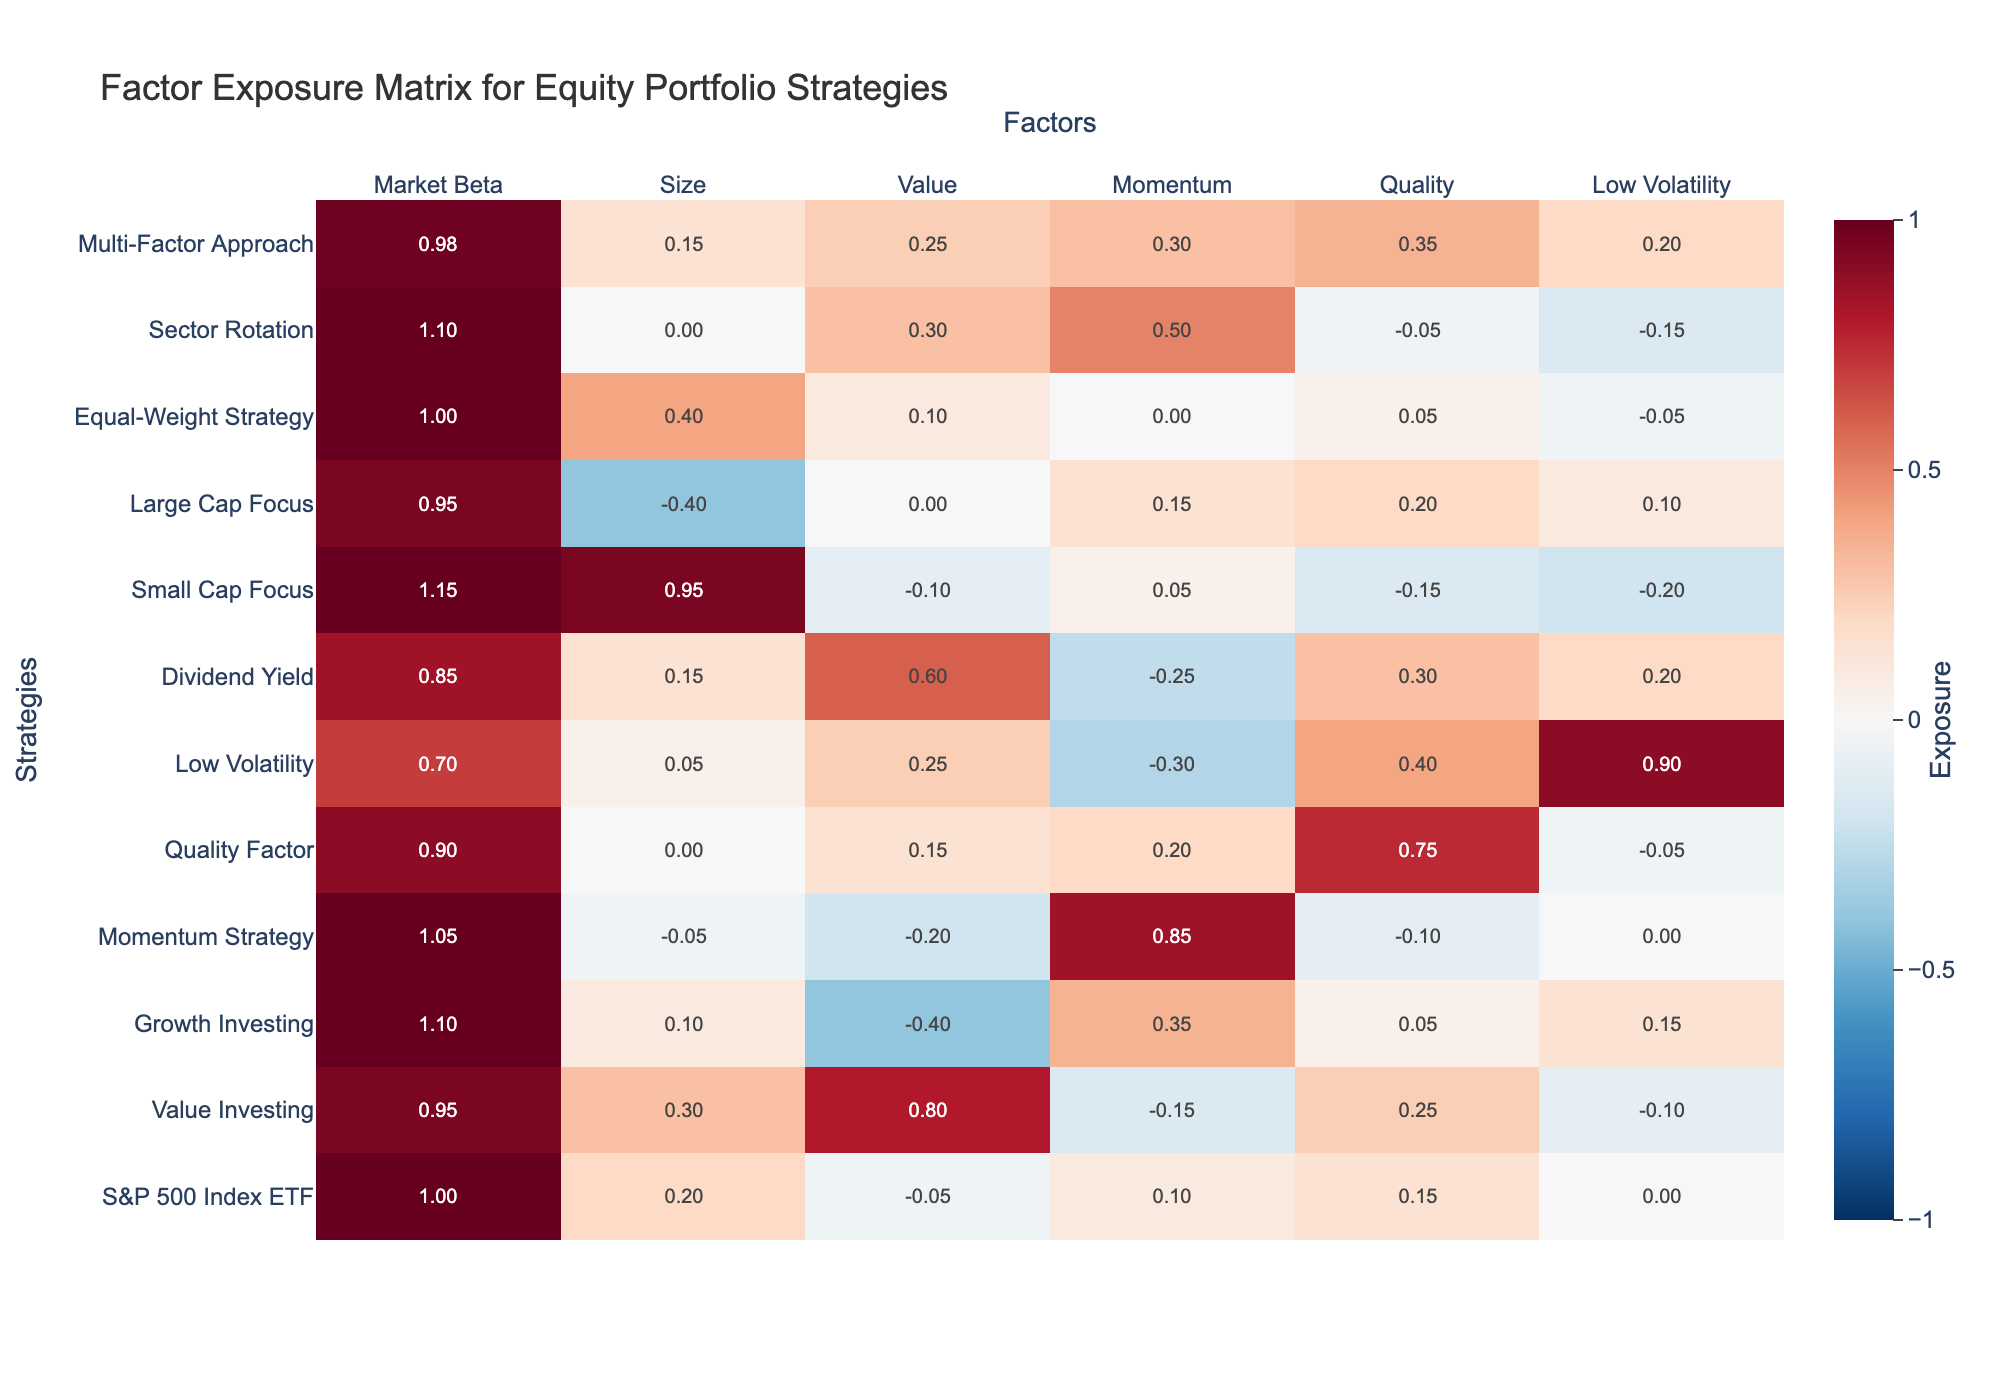What is the market beta for the Growth Investing strategy? The table shows the market beta values in the second column. For the Growth Investing strategy, the market beta is listed as 1.10.
Answer: 1.10 Which strategy has the highest exposure to Size? Looking at the Size column, the strategy with the highest exposure (0.95) is the Small Cap Focus.
Answer: Small Cap Focus Is the Low Volatility strategy more exposed to Quality or Value? In the Low Volatility row, the exposures are 0.40 for Quality and 0.25 for Value. Since 0.40 is greater than 0.25, Low Volatility is more exposed to Quality.
Answer: Yes, more exposed to Quality What is the sum of exposures to the Value factor across all strategies? By summing the Value exposures: -0.05 + 0.80 - 0.40 - 0.20 + 0.15 + 0.25 + 0.60 - 0.10 + 0.00 + 0.30 + 0.25 = 1.00.
Answer: 1.00 Which strategy is the least exposed to Momentum? Examining the Momentum column, the strategy with the lowest exposure is Low Volatility with -0.30.
Answer: Low Volatility Is the average exposure to the Size factor across all strategies positive or negative? To find the average, sum the Size exposures: 0.20 + 0.30 + 0.10 - 0.05 + 0.00 + 0.05 + 0.15 + 0.95 - 0.40 + 0.40 + 0.00 = 1.60. There are 11 strategies, so the average is 1.60/11 ≈ 0.15, which is positive.
Answer: Positive What strategy has the lowest exposure to Low Volatility? In the Low Volatility column, the lowest exposure is -0.20 from the Small Cap Focus strategy.
Answer: Small Cap Focus Which exposure is the most pronounced for the Value Investing strategy? Looking at the Value column for Value Investing, the exposure is high at 0.80, compared to other factors.
Answer: 0.80 What is the difference in Market Beta between the Large Cap Focus and the Momentum Strategy? The Market Beta for Large Cap Focus is 0.95 and for the Momentum Strategy, it is 1.05. The difference is 1.05 - 0.95 = 0.10.
Answer: 0.10 Identify which strategy has the highest exposure to Momentum and its value. In the Momentum column, the highest exposure is 0.85 from the Momentum Strategy.
Answer: Momentum Strategy, 0.85 Which two strategies have a negative exposure to all factors combined? Upon reviewing, both the Low Volatility and Small Cap Focus strategies have several negative exposures, particularly in categories like Momentum and Value.
Answer: Low Volatility and Small Cap Focus 